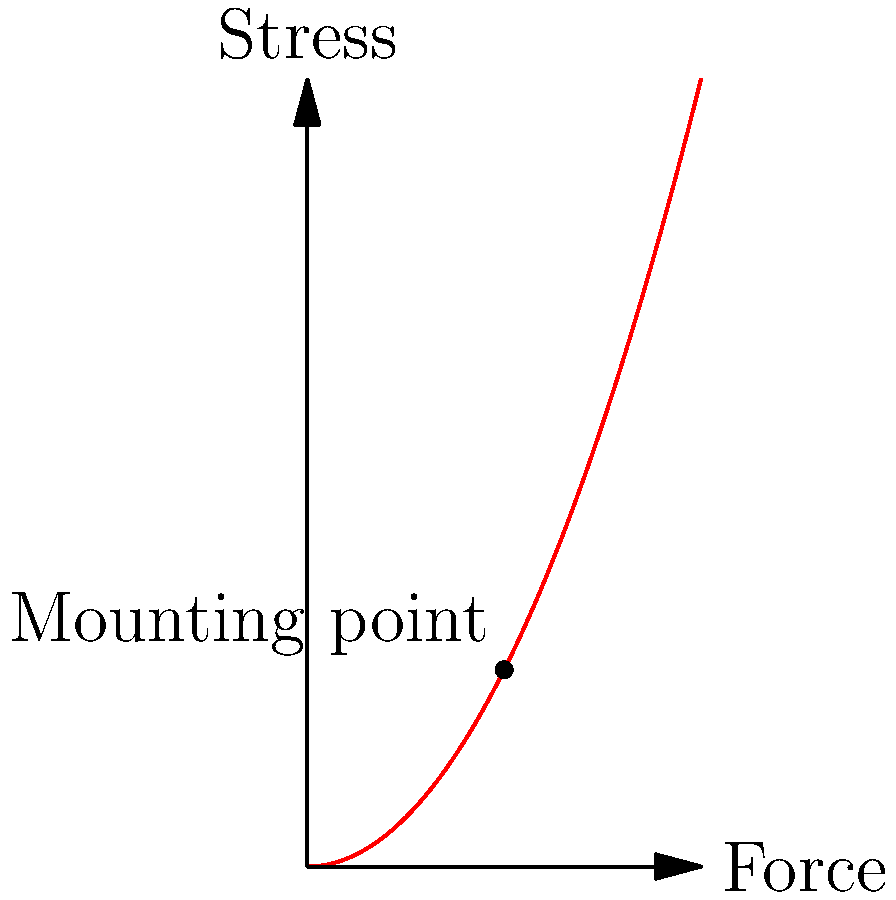In a solar panel mounting structure, the stress distribution follows a parabolic curve as shown in the graph. If the maximum stress occurs at the mounting point (2, 2), what is the equation of the stress distribution curve? To find the equation of the stress distribution curve, we'll follow these steps:

1. The general equation of a parabola is $y = ax^2 + bx + c$, where $a$, $b$, and $c$ are constants.

2. We know the vertex of the parabola is at (2, 2), which is the mounting point and the point of maximum stress.

3. For a parabola with vertex $(h, k)$, the equation is $y = a(x-h)^2 + k$.

4. Substituting our known vertex (2, 2), we get: $y = a(x-2)^2 + 2$

5. To find $a$, we can use the fact that the parabola passes through (0, 0):
   $0 = a(0-2)^2 + 2$
   $0 = 4a + 2$
   $-2 = 4a$
   $a = -\frac{1}{2}$

6. Substituting this value of $a$ into our equation:
   $y = -\frac{1}{2}(x-2)^2 + 2$

7. Expanding the equation:
   $y = -\frac{1}{2}(x^2 - 4x + 4) + 2$
   $y = -\frac{1}{2}x^2 + 2x - 2 + 2$
   $y = -\frac{1}{2}x^2 + 2x$

Therefore, the equation of the stress distribution curve is $y = -\frac{1}{2}x^2 + 2x$.
Answer: $y = -\frac{1}{2}x^2 + 2x$ 